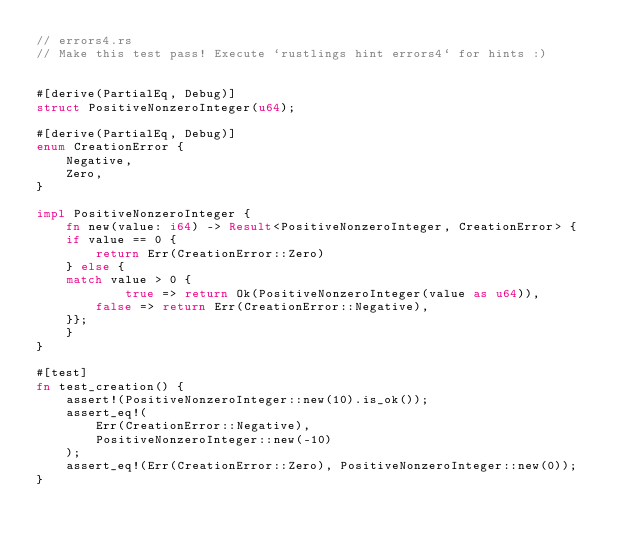<code> <loc_0><loc_0><loc_500><loc_500><_Rust_>// errors4.rs
// Make this test pass! Execute `rustlings hint errors4` for hints :)


#[derive(PartialEq, Debug)]
struct PositiveNonzeroInteger(u64);

#[derive(PartialEq, Debug)]
enum CreationError {
    Negative,
    Zero,
}

impl PositiveNonzeroInteger {
    fn new(value: i64) -> Result<PositiveNonzeroInteger, CreationError> {
	if value == 0 {
		return Err(CreationError::Zero)
	} else {
	match value > 0 {
        	true => return Ok(PositiveNonzeroInteger(value as u64)),
		false => return Err(CreationError::Negative),
	}};
    }
}

#[test]
fn test_creation() {
    assert!(PositiveNonzeroInteger::new(10).is_ok());
    assert_eq!(
        Err(CreationError::Negative),
        PositiveNonzeroInteger::new(-10)
    );
    assert_eq!(Err(CreationError::Zero), PositiveNonzeroInteger::new(0));
}
</code> 